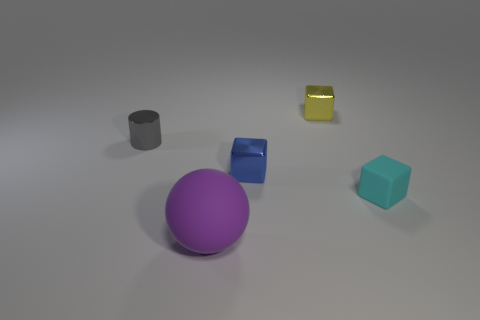There is a yellow metal object that is the same shape as the small blue metal thing; what is its size?
Provide a succinct answer. Small. Are there fewer small gray cylinders in front of the tiny blue metal object than tiny red metal objects?
Your response must be concise. No. Are there any gray metallic things?
Your answer should be very brief. Yes. What is the color of the matte object that is the same shape as the blue metallic thing?
Your response must be concise. Cyan. There is a matte object on the left side of the small blue cube; does it have the same color as the metallic cylinder?
Keep it short and to the point. No. Is the size of the blue shiny block the same as the yellow object?
Your answer should be compact. Yes. The tiny gray object that is the same material as the yellow object is what shape?
Your answer should be very brief. Cylinder. How many other things are there of the same shape as the small blue metallic thing?
Keep it short and to the point. 2. What shape is the small shiny object to the left of the rubber thing that is in front of the rubber thing behind the large purple sphere?
Ensure brevity in your answer.  Cylinder. How many cylinders are big brown rubber objects or large purple matte things?
Ensure brevity in your answer.  0. 